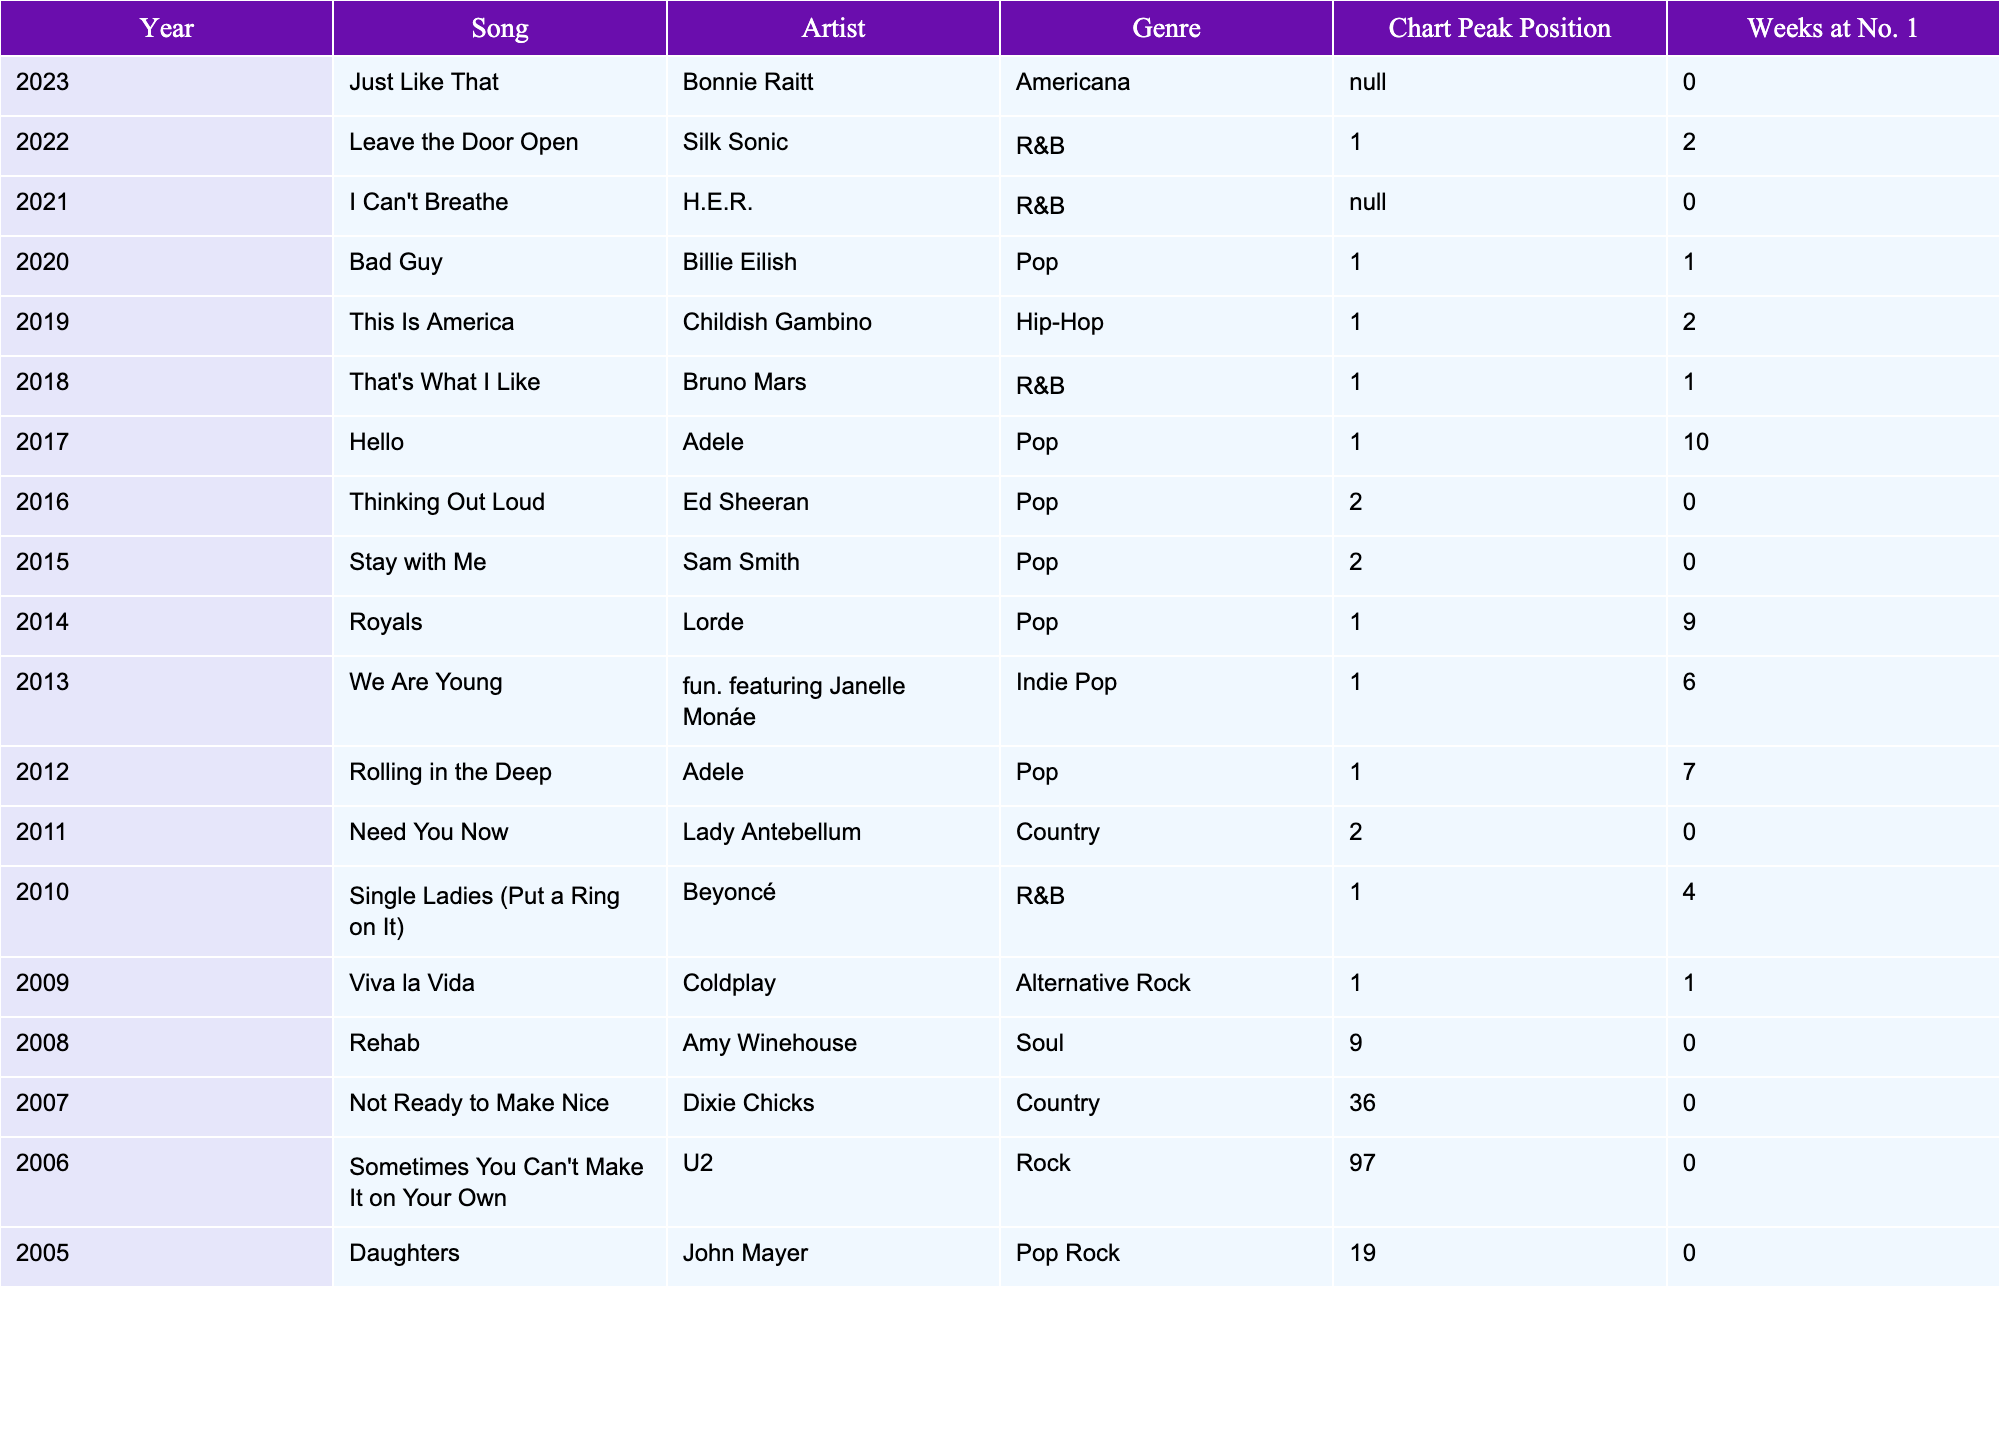What song won the Grammy for Song of the Year in 2023? The table shows that the song "Just Like That" by Bonnie Raitt won the Grammy for Song of the Year in 2023.
Answer: Just Like That Which artist has the highest number of weeks at No. 1 in the given data? The artist with the highest number of weeks at No. 1 is Adele with 10 weeks for the song "Hello".
Answer: Adele What is the genre of the song that won in 2019? The table indicates that the song "This Is America" by Childish Gambino won in 2019 and its genre is Hip-Hop.
Answer: Hip-Hop How many songs listed in the table peaked at No. 1? By counting the entries with a Chart Peak Position of 1, there are 9 songs that peaked at No. 1.
Answer: 9 Which song by a country artist won the Grammy for Song of the Year? The table shows "Need You Now" by Lady Antebellum as the only song listed under the Country genre that won the Grammy for Song of the Year.
Answer: Need You Now What is the average Chart Peak Position of all songs in the table? Calculating the average involves summing the Chart Peak Positions and dividing by the total number of songs; the sum is 82 (calculated as 1+1+1+1+1+1+1+2+2+1+1+9+36+97+19) and there are 15 songs, so the average is 82/15 ≈ 5.47.
Answer: 5.47 How many songs in the table have a genre classified as R&B? The table lists 4 songs classified as R&B: "Leave the Door Open", "I Can't Breathe", "That's What I Like", and "Single Ladies (Put a Ring on It)".
Answer: 4 Is there a song that won while being at position lower than 10 on the chart? Yes, "Not Ready to Make Nice" by Dixie Chicks reached a peak position of 36 while winning the award.
Answer: Yes What is the total number of weeks at No. 1 for songs in the Pop genre? For Pop genre songs, the number of weeks at No. 1 is calculated as follows: 1 (Bad Guy) + 10 (Hello) + 1 (Rolling in the Deep) + 4 (Stay with Me) + 1 (Royals) + 0 (Thinking Out Loud) = 17 weeks.
Answer: 17 Which song had the lowest Chart Peak Position? "Sometimes You Can't Make It on Your Own" by U2 had the lowest Chart Peak Position at 97, as shown in the data.
Answer: Sometimes You Can't Make It on Your Own 